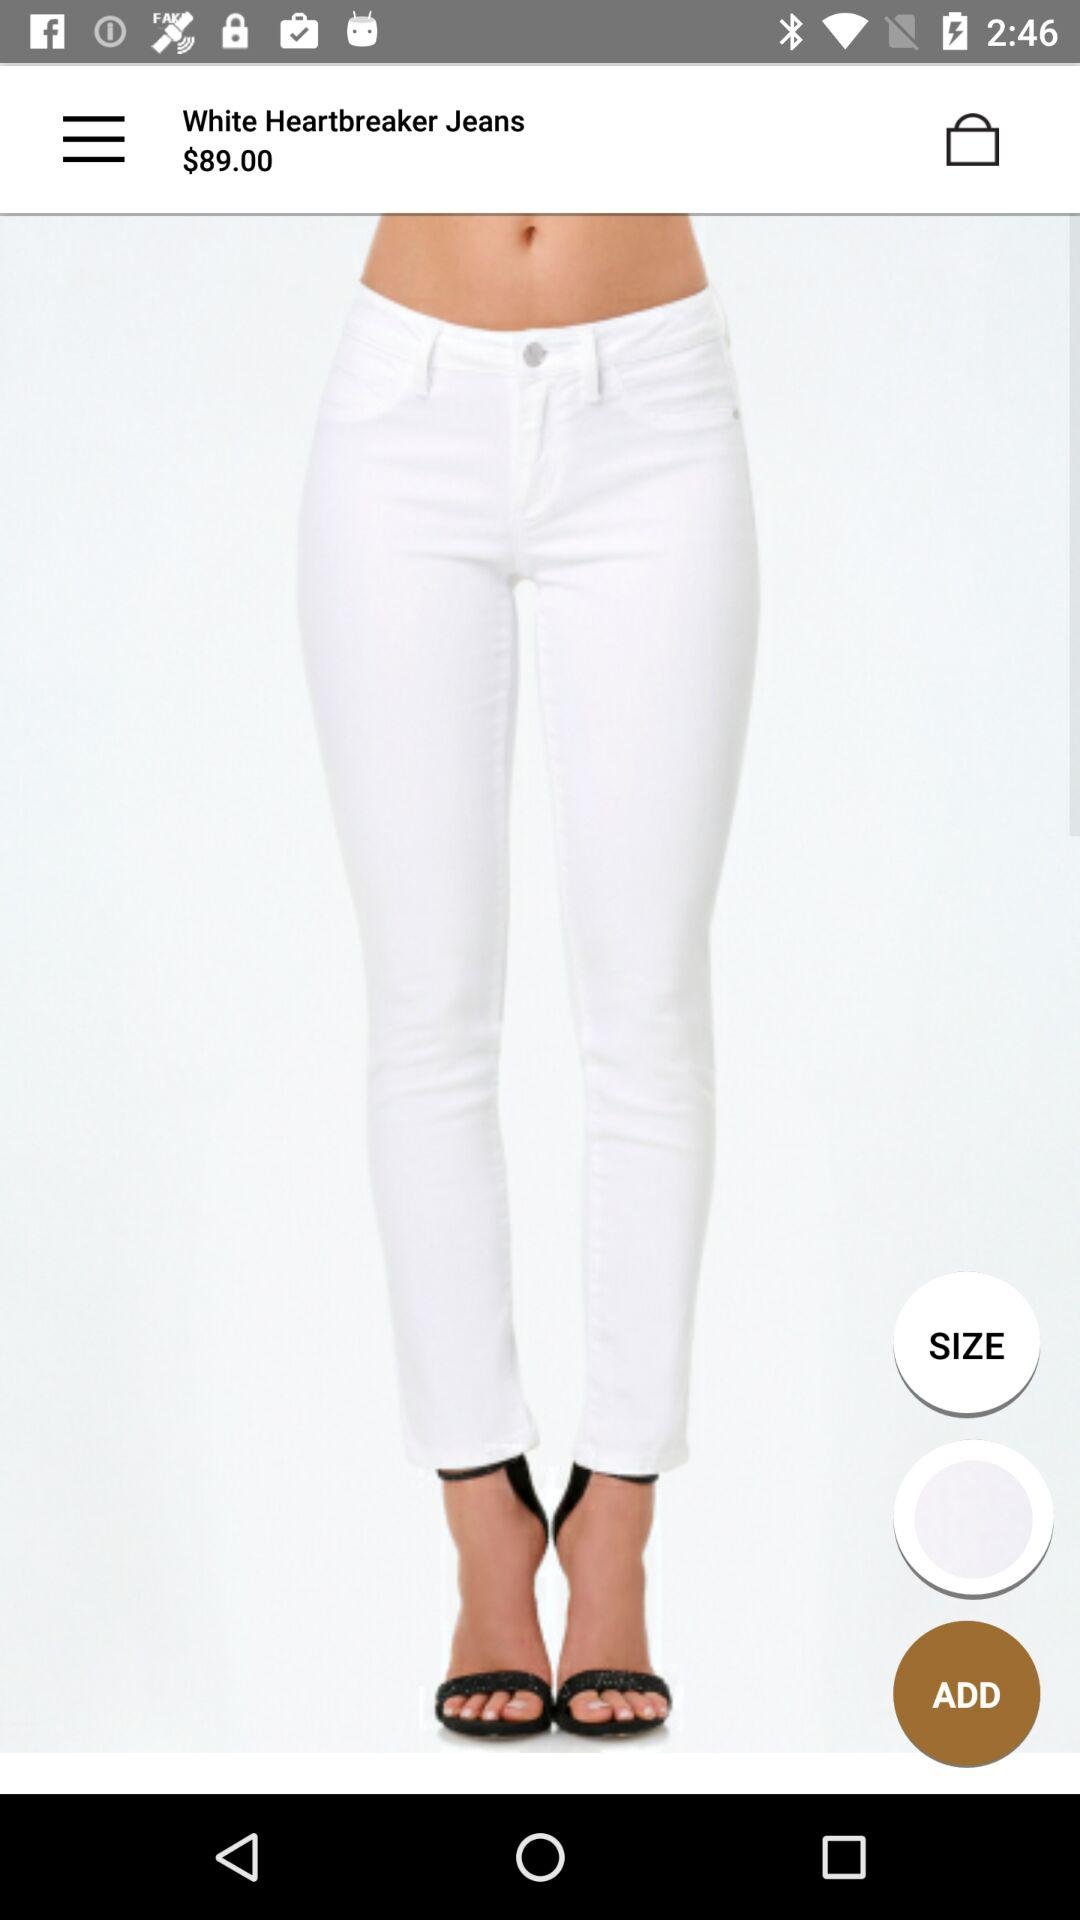What is the price of the White Heartbreaker Jeans? The price is $89. 